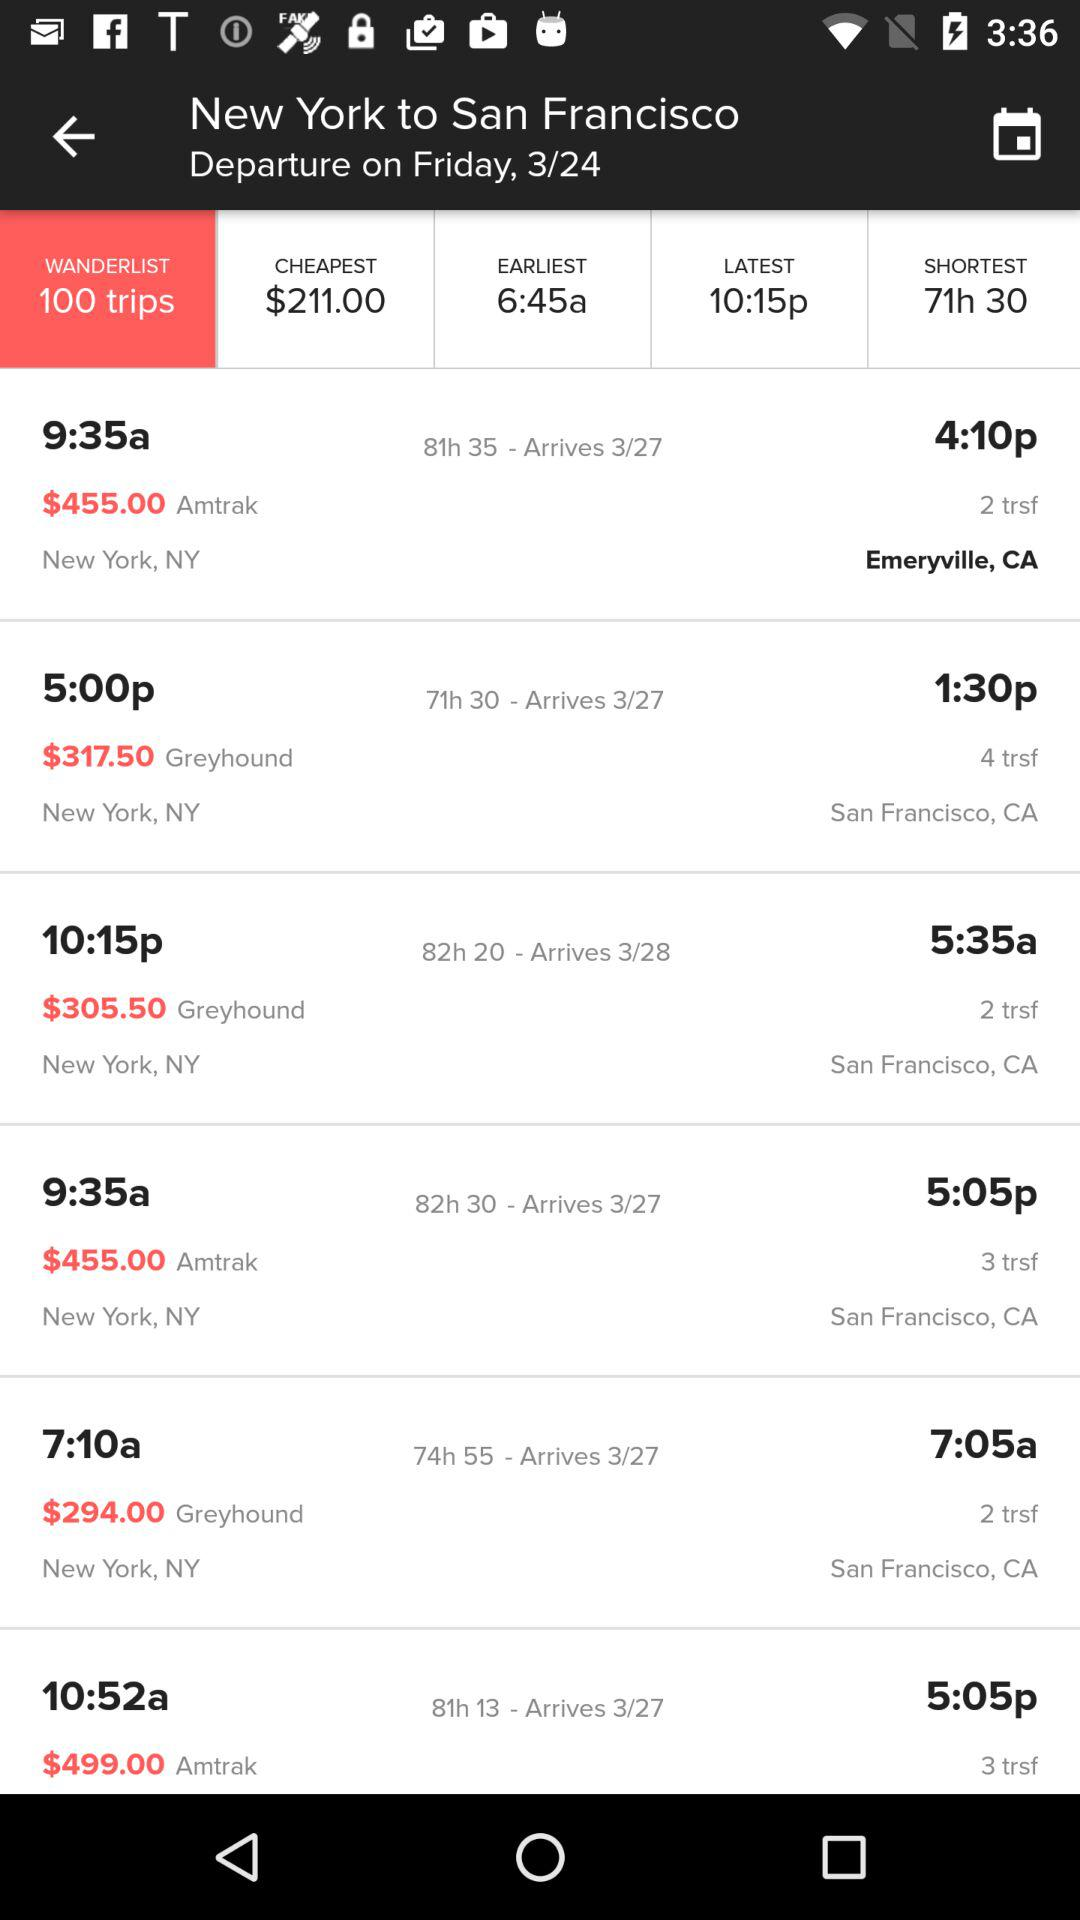What is the shortest time to travel? The shortest time is 71 hours and 30 minutes. 